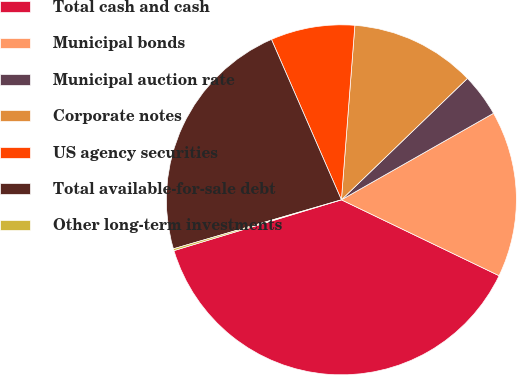<chart> <loc_0><loc_0><loc_500><loc_500><pie_chart><fcel>Total cash and cash<fcel>Municipal bonds<fcel>Municipal auction rate<fcel>Corporate notes<fcel>US agency securities<fcel>Total available-for-sale debt<fcel>Other long-term investments<nl><fcel>38.17%<fcel>15.37%<fcel>3.97%<fcel>11.57%<fcel>7.77%<fcel>22.97%<fcel>0.17%<nl></chart> 